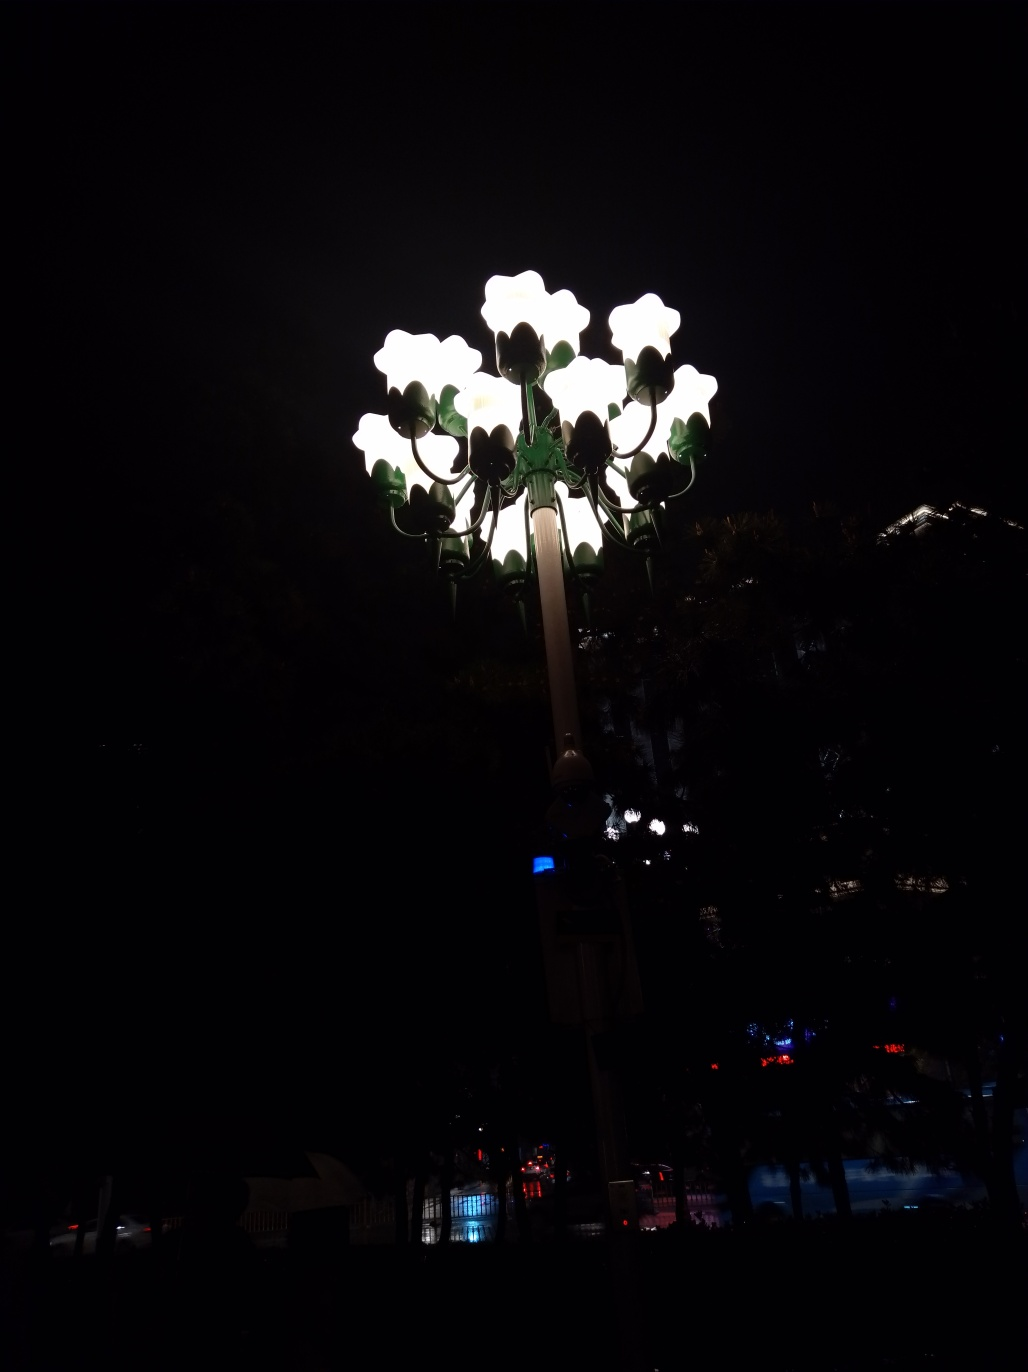What do you imagine is the purpose of these uniquely designed lamps? The design of the lamps, which resembles a bunch of flowers, seems to serve an aesthetic purpose beyond mere illumination. They may be part of a park or garden where the aim is to enhance the beauty of the space, providing light in a manner that complements the natural surroundings and possibly during special events or seasons. 